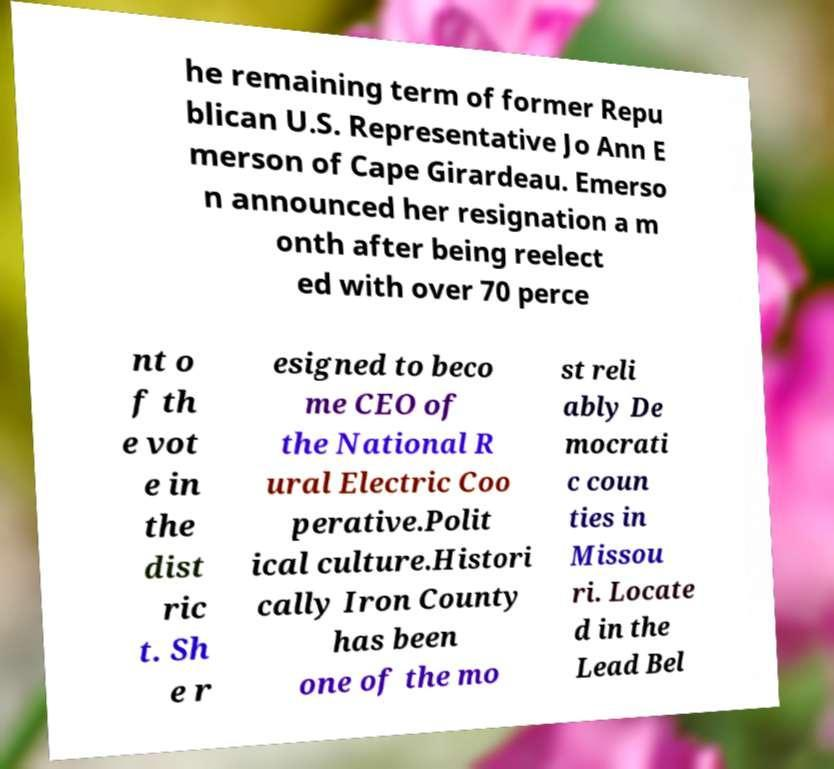What messages or text are displayed in this image? I need them in a readable, typed format. he remaining term of former Repu blican U.S. Representative Jo Ann E merson of Cape Girardeau. Emerso n announced her resignation a m onth after being reelect ed with over 70 perce nt o f th e vot e in the dist ric t. Sh e r esigned to beco me CEO of the National R ural Electric Coo perative.Polit ical culture.Histori cally Iron County has been one of the mo st reli ably De mocrati c coun ties in Missou ri. Locate d in the Lead Bel 